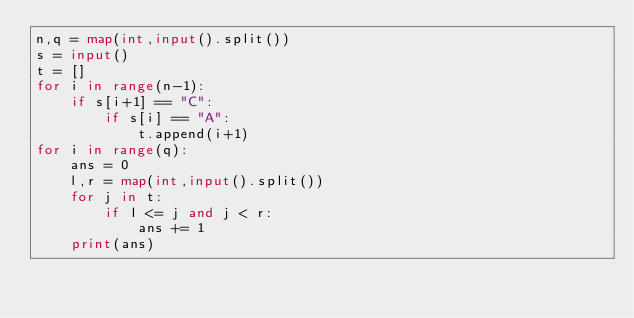<code> <loc_0><loc_0><loc_500><loc_500><_Python_>n,q = map(int,input().split())
s = input()
t = []
for i in range(n-1):
    if s[i+1] == "C":
        if s[i] == "A":
            t.append(i+1)
for i in range(q):
    ans = 0
    l,r = map(int,input().split())
    for j in t:
        if l <= j and j < r:
            ans += 1
    print(ans)</code> 